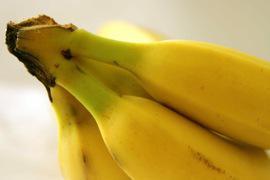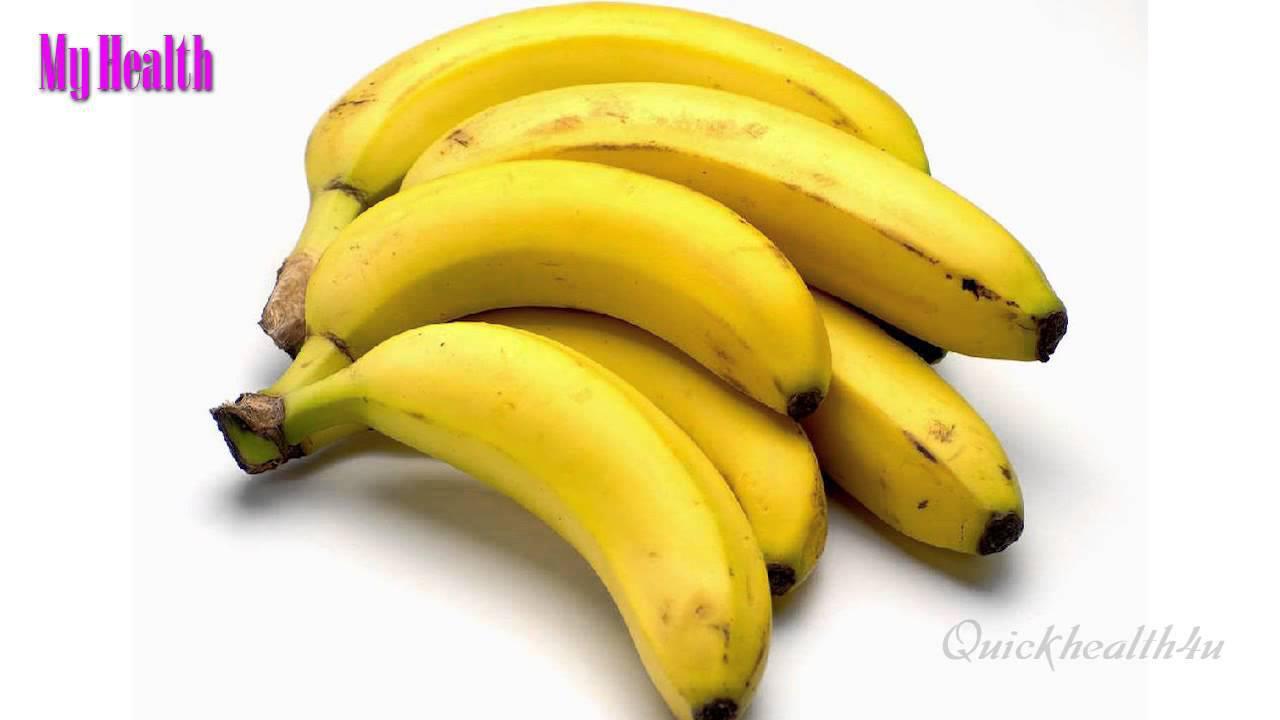The first image is the image on the left, the second image is the image on the right. For the images displayed, is the sentence "In one image, the inside of a banana is visible." factually correct? Answer yes or no. No. The first image is the image on the left, the second image is the image on the right. For the images displayed, is the sentence "The left image includes unpeeled bananas with at least one other item, and the right image shows what is under a banana peel." factually correct? Answer yes or no. No. 